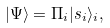Convert formula to latex. <formula><loc_0><loc_0><loc_500><loc_500>| \Psi \rangle = \Pi _ { i } | s _ { i } \rangle _ { i } ,</formula> 